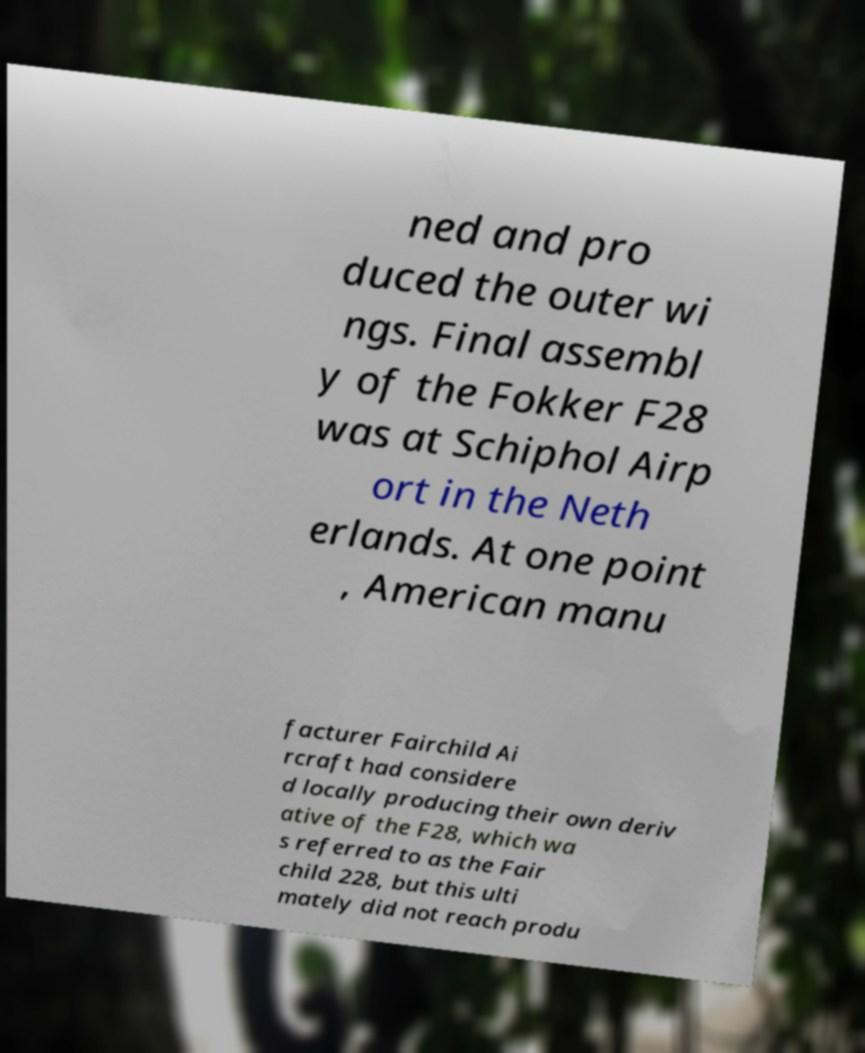There's text embedded in this image that I need extracted. Can you transcribe it verbatim? ned and pro duced the outer wi ngs. Final assembl y of the Fokker F28 was at Schiphol Airp ort in the Neth erlands. At one point , American manu facturer Fairchild Ai rcraft had considere d locally producing their own deriv ative of the F28, which wa s referred to as the Fair child 228, but this ulti mately did not reach produ 